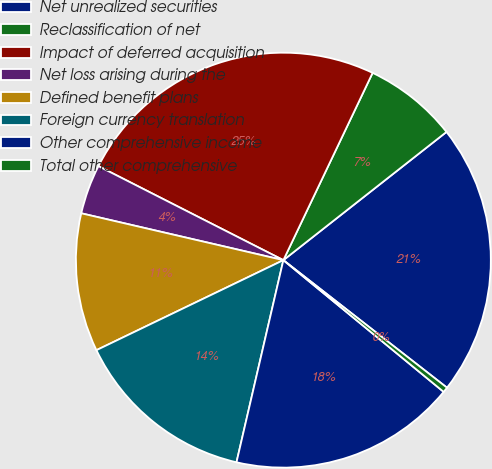Convert chart. <chart><loc_0><loc_0><loc_500><loc_500><pie_chart><fcel>Net unrealized securities<fcel>Reclassification of net<fcel>Impact of deferred acquisition<fcel>Net loss arising during the<fcel>Defined benefit plans<fcel>Foreign currency translation<fcel>Other comprehensive income<fcel>Total other comprehensive<nl><fcel>21.14%<fcel>7.32%<fcel>24.59%<fcel>3.86%<fcel>10.77%<fcel>14.23%<fcel>17.68%<fcel>0.41%<nl></chart> 